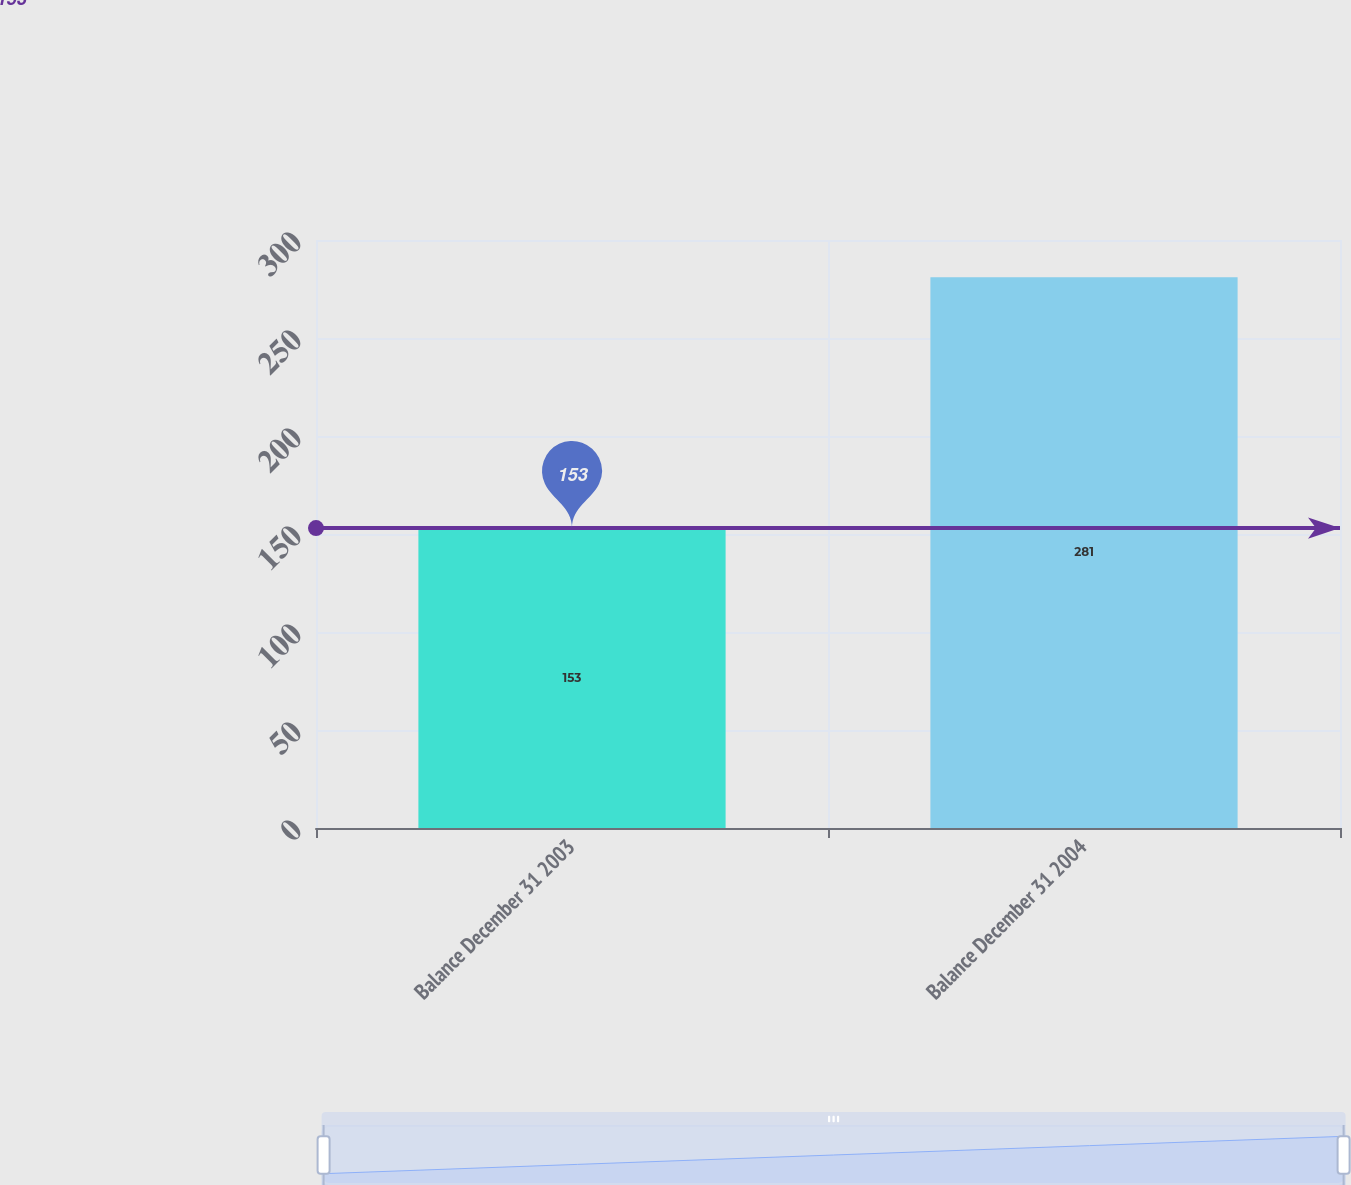<chart> <loc_0><loc_0><loc_500><loc_500><bar_chart><fcel>Balance December 31 2003<fcel>Balance December 31 2004<nl><fcel>153<fcel>281<nl></chart> 